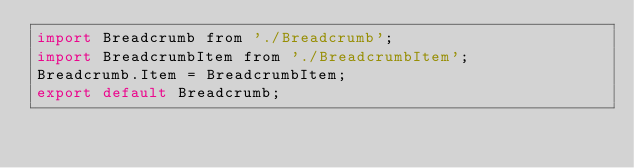Convert code to text. <code><loc_0><loc_0><loc_500><loc_500><_JavaScript_>import Breadcrumb from './Breadcrumb';
import BreadcrumbItem from './BreadcrumbItem';
Breadcrumb.Item = BreadcrumbItem;
export default Breadcrumb;</code> 